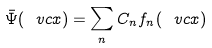<formula> <loc_0><loc_0><loc_500><loc_500>\bar { \Psi } ( \ v c { x } ) = \sum _ { n } C _ { n } f _ { n } ( \ v c { x } )</formula> 